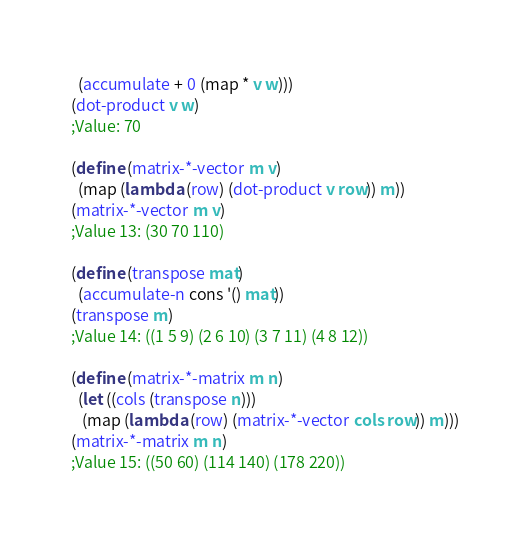<code> <loc_0><loc_0><loc_500><loc_500><_Scheme_>  (accumulate + 0 (map * v w)))
(dot-product v w)
;Value: 70

(define (matrix-*-vector m v)
  (map (lambda (row) (dot-product v row)) m))
(matrix-*-vector m v)
;Value 13: (30 70 110)

(define (transpose mat)
  (accumulate-n cons '() mat))
(transpose m)
;Value 14: ((1 5 9) (2 6 10) (3 7 11) (4 8 12))

(define (matrix-*-matrix m n)
  (let ((cols (transpose n)))
   (map (lambda (row) (matrix-*-vector cols row)) m)))
(matrix-*-matrix m n)
;Value 15: ((50 60) (114 140) (178 220))

</code> 